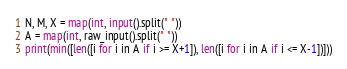<code> <loc_0><loc_0><loc_500><loc_500><_Python_>N, M, X = map(int, input().split(" "))
A = map(int, raw_input().split(" "))
print(min([len([i for i in A if i >= X+1]), len([i for i in A if i <= X-1])]))</code> 